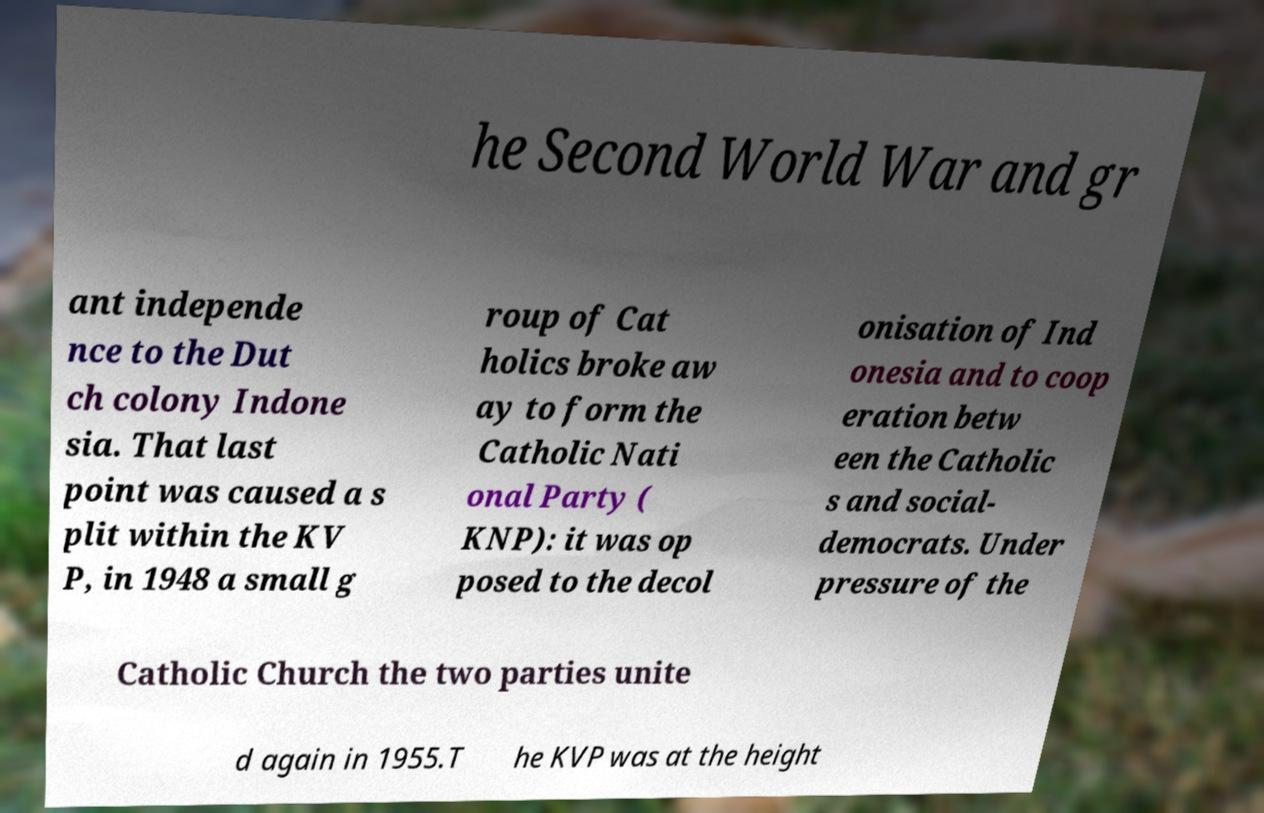Could you assist in decoding the text presented in this image and type it out clearly? he Second World War and gr ant independe nce to the Dut ch colony Indone sia. That last point was caused a s plit within the KV P, in 1948 a small g roup of Cat holics broke aw ay to form the Catholic Nati onal Party ( KNP): it was op posed to the decol onisation of Ind onesia and to coop eration betw een the Catholic s and social- democrats. Under pressure of the Catholic Church the two parties unite d again in 1955.T he KVP was at the height 